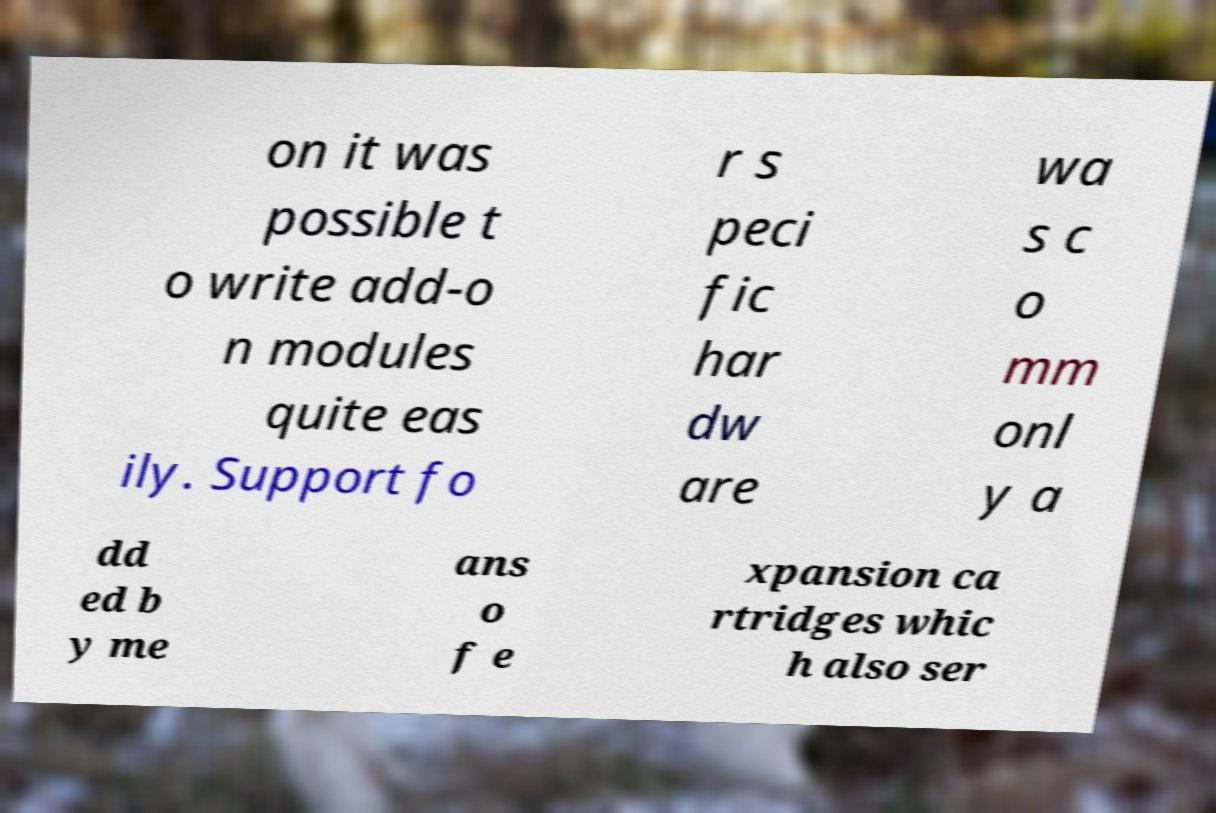Please read and relay the text visible in this image. What does it say? on it was possible t o write add-o n modules quite eas ily. Support fo r s peci fic har dw are wa s c o mm onl y a dd ed b y me ans o f e xpansion ca rtridges whic h also ser 